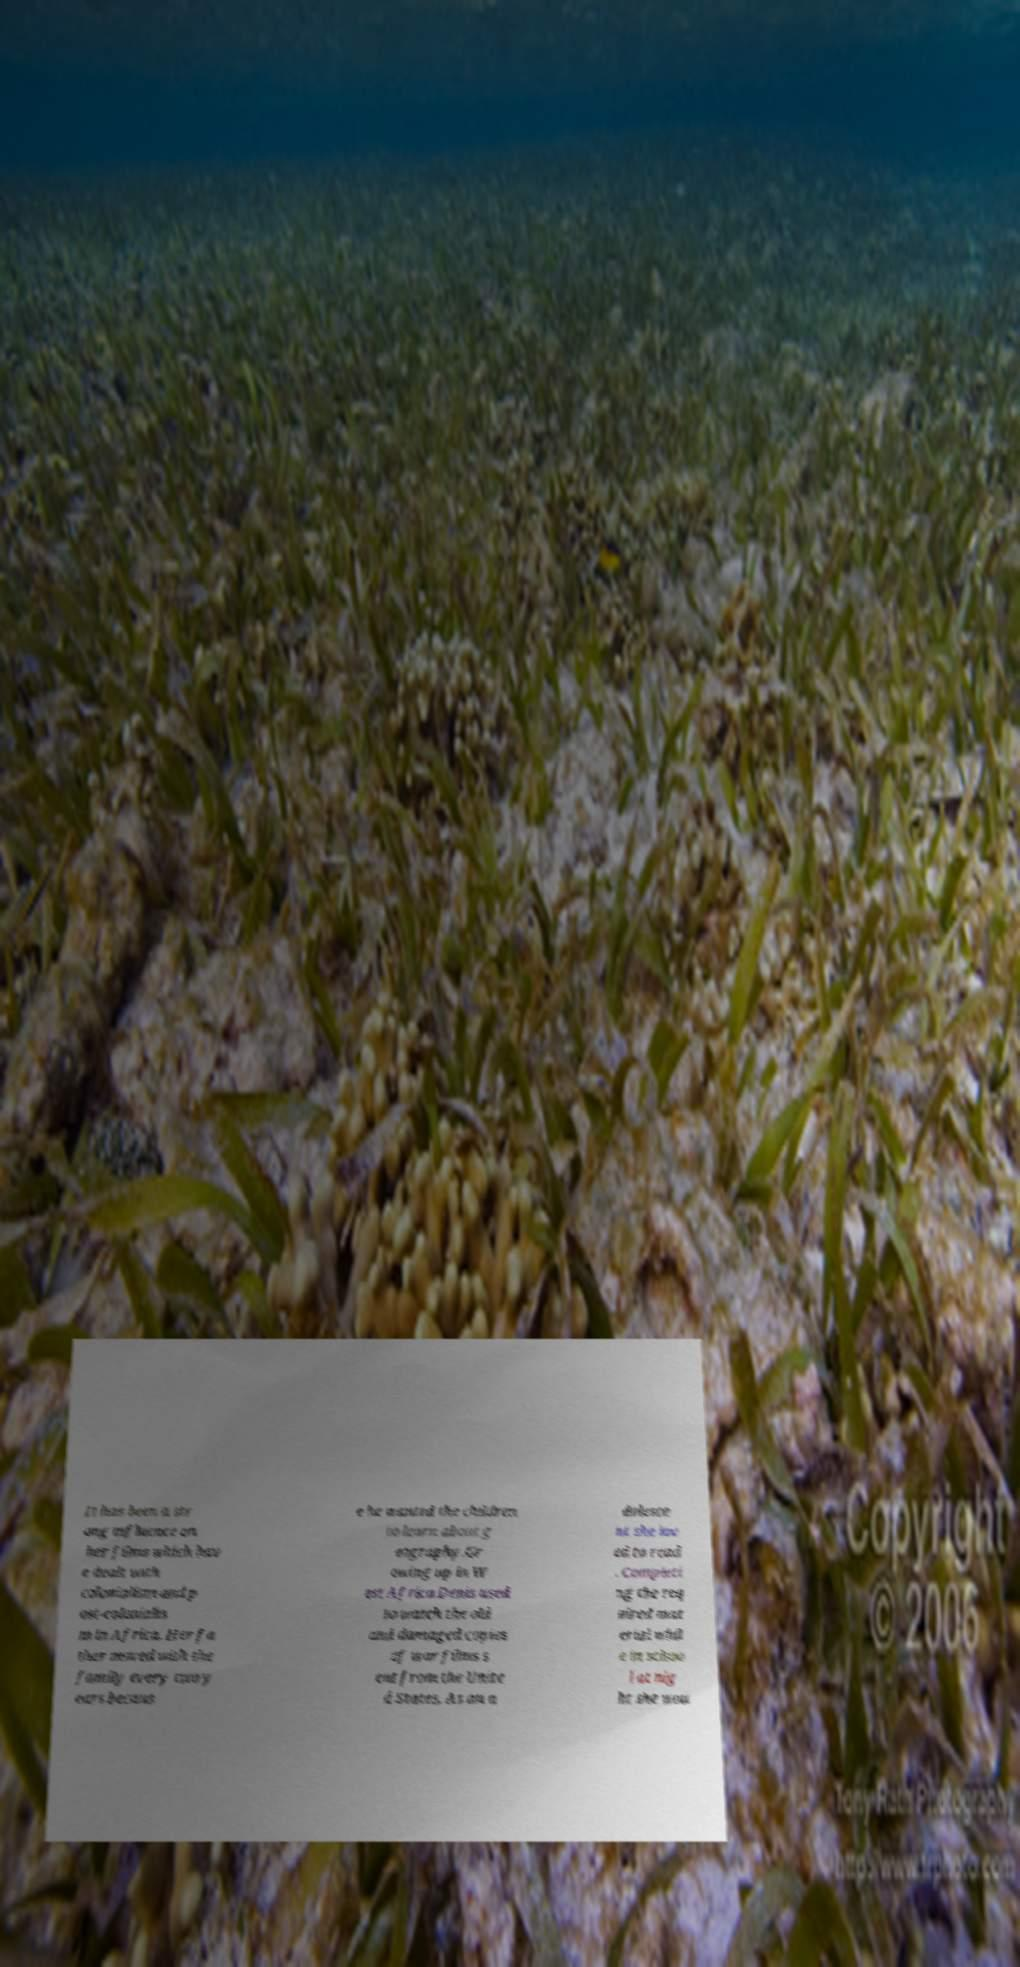Could you assist in decoding the text presented in this image and type it out clearly? It has been a str ong influence on her films which hav e dealt with colonialism and p ost-colonialis m in Africa. Her fa ther moved with the family every two y ears becaus e he wanted the children to learn about g eography.Gr owing up in W est Africa Denis used to watch the old and damaged copies of war films s ent from the Unite d States. As an a dolesce nt she lov ed to read . Completi ng the req uired mat erial whil e in schoo l at nig ht she wou 